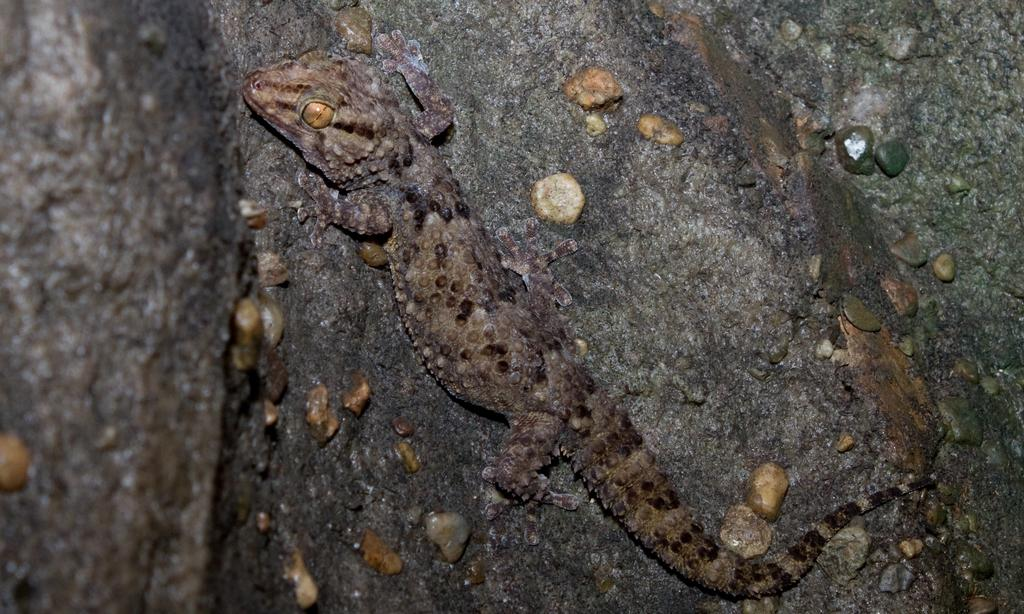What type of animal is in the image? There is a lizard in the image. Where is the lizard located? The lizard is on the trunk of a tree. What type of button can be seen on the lizard's back in the image? There is no button present on the lizard's back in the image. 